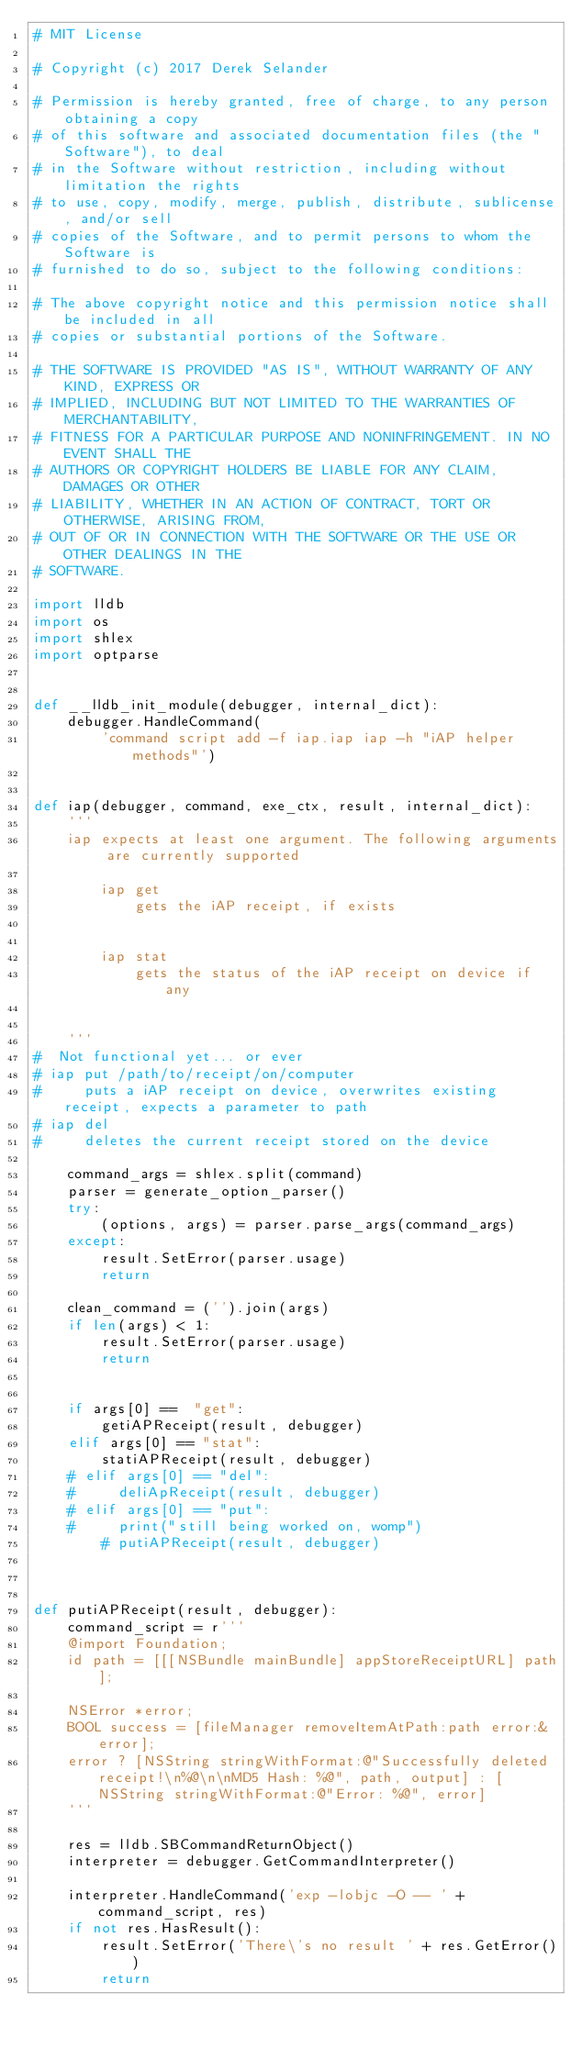Convert code to text. <code><loc_0><loc_0><loc_500><loc_500><_Python_># MIT License

# Copyright (c) 2017 Derek Selander

# Permission is hereby granted, free of charge, to any person obtaining a copy
# of this software and associated documentation files (the "Software"), to deal
# in the Software without restriction, including without limitation the rights
# to use, copy, modify, merge, publish, distribute, sublicense, and/or sell
# copies of the Software, and to permit persons to whom the Software is
# furnished to do so, subject to the following conditions:

# The above copyright notice and this permission notice shall be included in all
# copies or substantial portions of the Software.

# THE SOFTWARE IS PROVIDED "AS IS", WITHOUT WARRANTY OF ANY KIND, EXPRESS OR
# IMPLIED, INCLUDING BUT NOT LIMITED TO THE WARRANTIES OF MERCHANTABILITY,
# FITNESS FOR A PARTICULAR PURPOSE AND NONINFRINGEMENT. IN NO EVENT SHALL THE
# AUTHORS OR COPYRIGHT HOLDERS BE LIABLE FOR ANY CLAIM, DAMAGES OR OTHER
# LIABILITY, WHETHER IN AN ACTION OF CONTRACT, TORT OR OTHERWISE, ARISING FROM,
# OUT OF OR IN CONNECTION WITH THE SOFTWARE OR THE USE OR OTHER DEALINGS IN THE
# SOFTWARE.

import lldb
import os
import shlex
import optparse


def __lldb_init_module(debugger, internal_dict):
    debugger.HandleCommand(
        'command script add -f iap.iap iap -h "iAP helper methods"')


def iap(debugger, command, exe_ctx, result, internal_dict):
    '''
    iap expects at least one argument. The following arguments are currently supported

        iap get 
            gets the iAP receipt, if exists


        iap stat 
            gets the status of the iAP receipt on device if any


    '''
#  Not functional yet... or ever
# iap put /path/to/receipt/on/computer
#     puts a iAP receipt on device, overwrites existing receipt, expects a parameter to path
# iap del
#     deletes the current receipt stored on the device

    command_args = shlex.split(command)
    parser = generate_option_parser()
    try:
        (options, args) = parser.parse_args(command_args)
    except:
        result.SetError(parser.usage)
        return

    clean_command = ('').join(args)
    if len(args) < 1:
        result.SetError(parser.usage)
        return


    if args[0] ==  "get":
        getiAPReceipt(result, debugger)
    elif args[0] == "stat":
        statiAPReceipt(result, debugger)
    # elif args[0] == "del":
    #     deliApReceipt(result, debugger)
    # elif args[0] == "put":
    #     print("still being worked on, womp")
        # putiAPReceipt(result, debugger)



def putiAPReceipt(result, debugger):
    command_script = r'''
    @import Foundation; 
    id path = [[[NSBundle mainBundle] appStoreReceiptURL] path]; 

    NSError *error;
    BOOL success = [fileManager removeItemAtPath:path error:&error];
    error ? [NSString stringWithFormat:@"Successfully deleted receipt!\n%@\n\nMD5 Hash: %@", path, output] : [NSString stringWithFormat:@"Error: %@", error]
    '''

    res = lldb.SBCommandReturnObject()
    interpreter = debugger.GetCommandInterpreter()

    interpreter.HandleCommand('exp -lobjc -O -- ' + command_script, res)
    if not res.HasResult():
        result.SetError('There\'s no result ' + res.GetError())
        return
</code> 